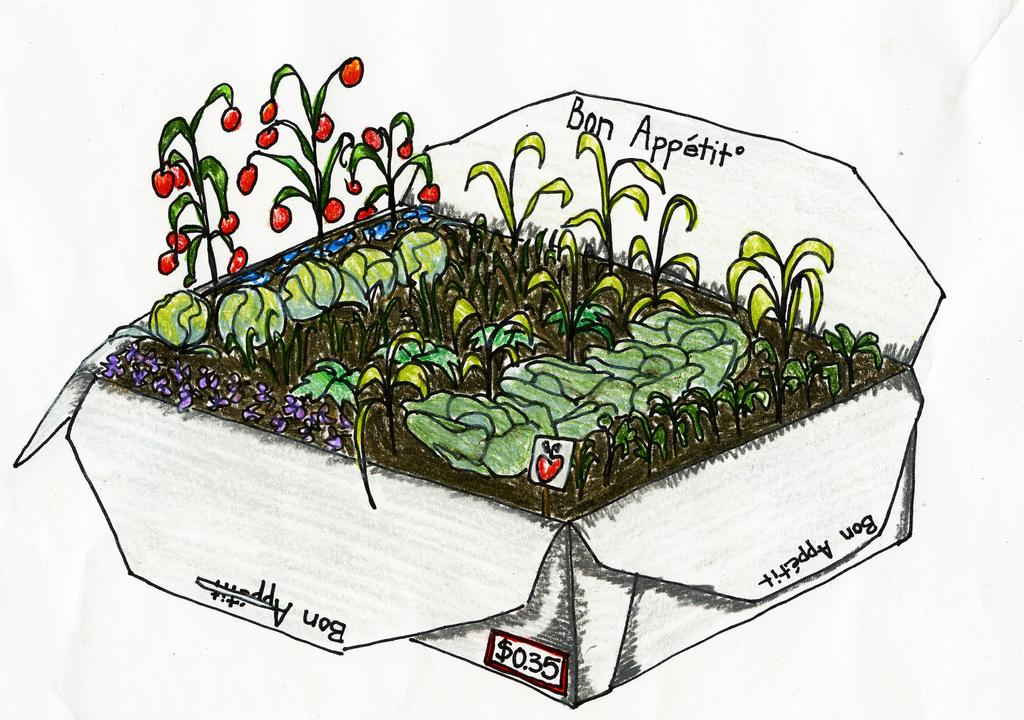What type of artwork is depicted in the image? The image contains paintings of houseplants. Are there any words or letters in the image? Yes, there is text in the image. What can be inferred about the medium of the artwork? The image appears to be a painting. Can you touch the wax used to create the paintings in the image? There is no wax present in the image, as it contains paintings of houseplants and not actual wax sculptures. What type of alarm is depicted in the image? There is no alarm present in the image; it features paintings of houseplants and text. 